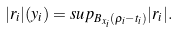<formula> <loc_0><loc_0><loc_500><loc_500>| r _ { i } | ( y _ { i } ) = s u p _ { B _ { x _ { i } } ( \rho _ { i } - t _ { i } ) } | r _ { i } | .</formula> 